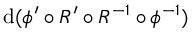<formula> <loc_0><loc_0><loc_500><loc_500>d ( \phi ^ { \prime } \circ R ^ { \prime } \circ R ^ { - 1 } \circ \phi ^ { - 1 } )</formula> 